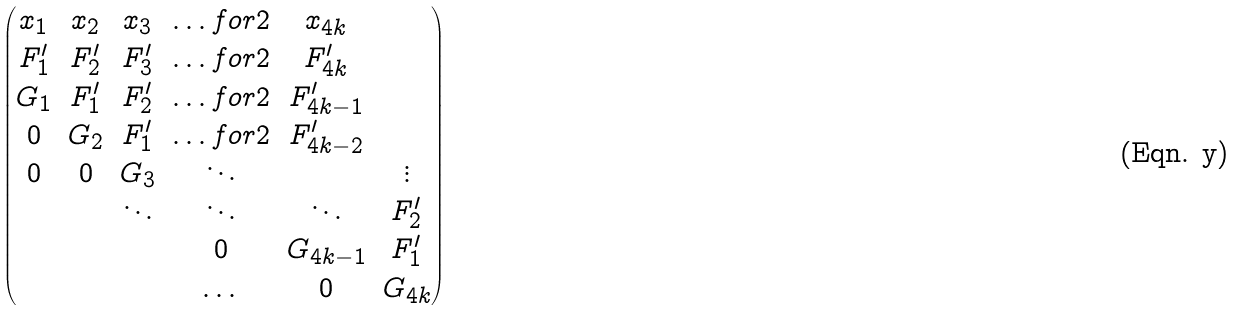Convert formula to latex. <formula><loc_0><loc_0><loc_500><loc_500>\begin{pmatrix} x _ { 1 } & x _ { 2 } & x _ { 3 } & \hdots f o r 2 & x _ { 4 k } \\ F ^ { \prime } _ { 1 } & F ^ { \prime } _ { 2 } & F ^ { \prime } _ { 3 } & \hdots f o r 2 & F ^ { \prime } _ { 4 k } \\ G _ { 1 } & F ^ { \prime } _ { 1 } & F ^ { \prime } _ { 2 } & \hdots f o r 2 & F ^ { \prime } _ { 4 k - 1 } \\ 0 & G _ { 2 } & F ^ { \prime } _ { 1 } & \hdots f o r 2 & F ^ { \prime } _ { 4 k - 2 } \\ 0 & 0 & G _ { 3 } & \ddots & & \vdots \\ & & \ddots & \ddots & \ddots & F ^ { \prime } _ { 2 } \\ & & & 0 & G _ { 4 k - 1 } & F ^ { \prime } _ { 1 } \\ & & & \dots & 0 & G _ { 4 k } \end{pmatrix}</formula> 